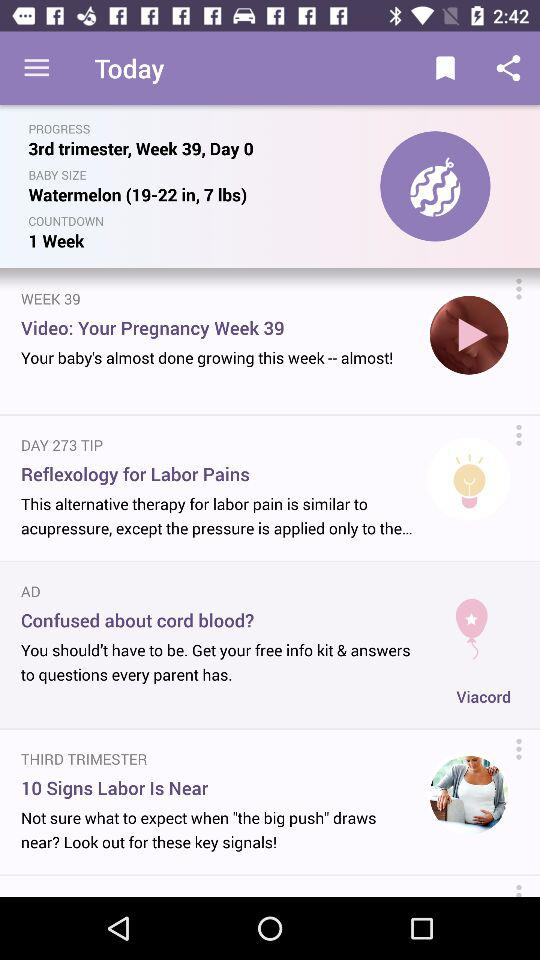What is the progress of the baby? The progress of the baby is "3rd trimester, Week 39, Day 0". 